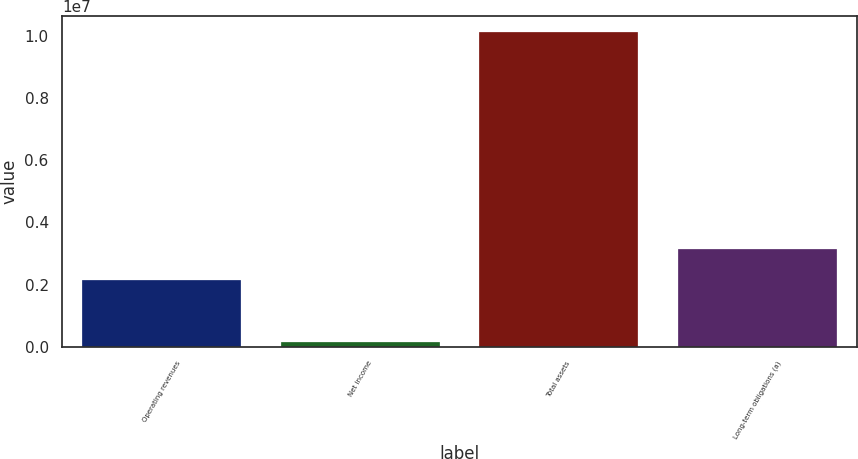<chart> <loc_0><loc_0><loc_500><loc_500><bar_chart><fcel>Operating revenues<fcel>Net income<fcel>Total assets<fcel>Long-term obligations (a)<nl><fcel>2.13992e+06<fcel>139844<fcel>1.0134e+07<fcel>3.13934e+06<nl></chart> 